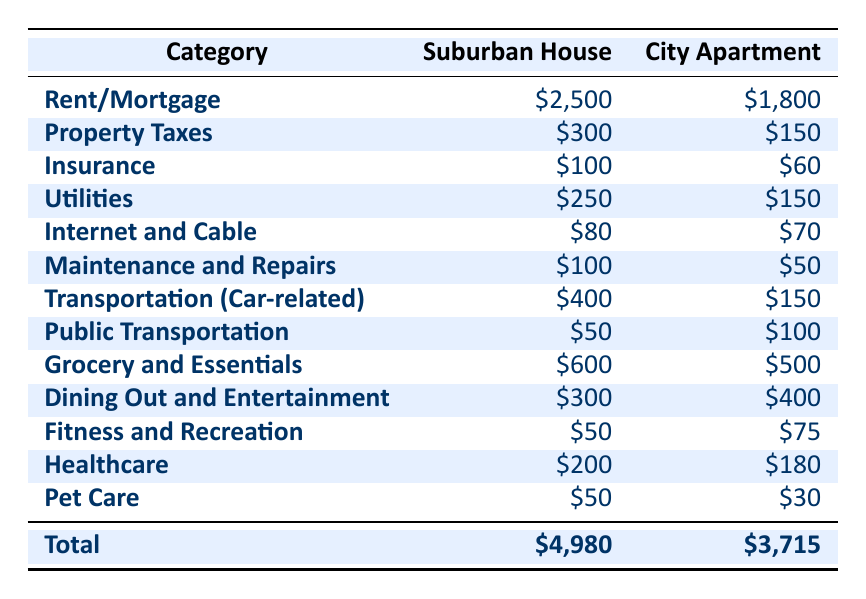What is the total monthly cost of living in a suburban house? The total monthly cost for the suburban house is listed at the bottom of the table, which is $4,980.
Answer: $4,980 What is the monthly rent/mortgage for the city apartment? The rent/mortgage for the city apartment is directly given in the table under the category 'Rent/Mortgage,' which is $1,800.
Answer: $1,800 Is it cheaper to insure a city apartment compared to a suburban house? The insurance cost for the city apartment is $60 while for the suburban house it is $100. Since $60 is less than $100, it is indeed cheaper to insure a city apartment.
Answer: Yes What is the difference in transportation costs between the suburban house and the city apartment? The transportation cost for the suburban house is $400, and for the city apartment, it is $150. The difference is calculated by subtracting the city apartment cost from the suburban house cost: $400 - $150 = $250.
Answer: $250 What category has the highest cost in the suburban house? By reviewing the categories, the rent/mortgage is the highest cost at $2,500 compared to all other categories in the suburban house.
Answer: Rent/Mortgage If one were to switch from the suburban house to the city apartment, how much would they save on property taxes? The property tax for the suburban house is $300 and for the city apartment is $150. The savings would be the difference: $300 - $150 = $150.
Answer: $150 What is the total monthly cost of living in the city apartment compared to the suburban house? The total for the city apartment is $3,715 and for the suburban house it is $4,980. The city apartment is $4,980 - $3,715 = $1,265 cheaper per month.
Answer: $1,265 Are the grocery costs higher in the suburban house than in the city apartment? The grocery cost for the suburban house is $600, while for the city apartment it is $500. Since $600 is greater than $500, yes, the grocery costs are higher in the suburban house.
Answer: Yes What is the sum of all monthly costs for the suburban house? Adding all the individual costs for the suburban house: $2,500 (Rent) + $300 (Taxes) + $100 (Insurance) + $250 (Utilities) + $80 (Internet) + $100 (Maintenance) + $400 (Transportation) + $50 (Public Transport) + $600 (Grocery) + $300 (Dining) + $50 (Fitness) + $200 (Healthcare) + $50 (Pet Care) = $4,980, which is already provided as the total.
Answer: $4,980 